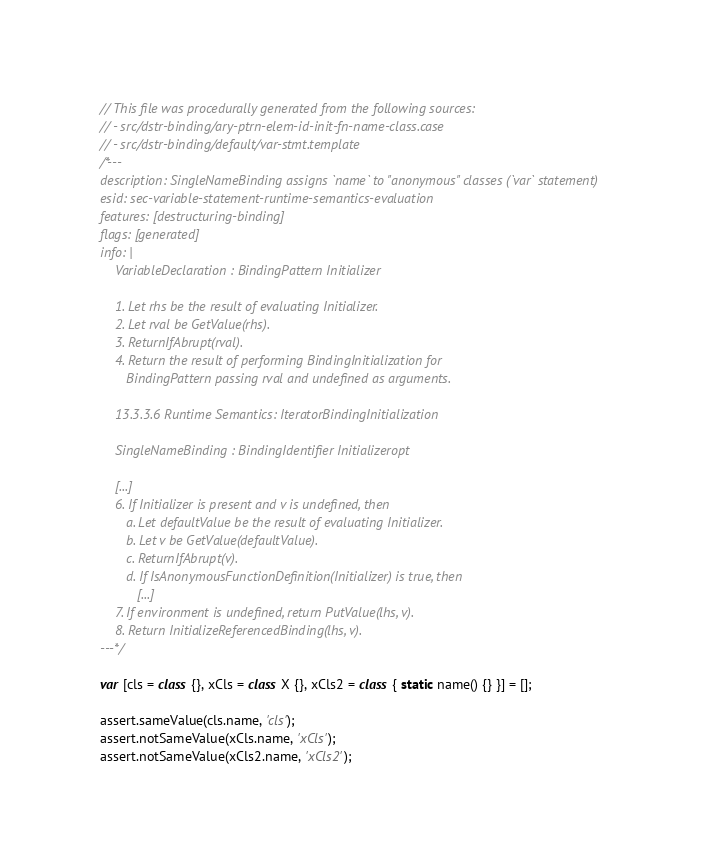Convert code to text. <code><loc_0><loc_0><loc_500><loc_500><_JavaScript_>// This file was procedurally generated from the following sources:
// - src/dstr-binding/ary-ptrn-elem-id-init-fn-name-class.case
// - src/dstr-binding/default/var-stmt.template
/*---
description: SingleNameBinding assigns `name` to "anonymous" classes (`var` statement)
esid: sec-variable-statement-runtime-semantics-evaluation
features: [destructuring-binding]
flags: [generated]
info: |
    VariableDeclaration : BindingPattern Initializer

    1. Let rhs be the result of evaluating Initializer.
    2. Let rval be GetValue(rhs).
    3. ReturnIfAbrupt(rval).
    4. Return the result of performing BindingInitialization for
       BindingPattern passing rval and undefined as arguments.

    13.3.3.6 Runtime Semantics: IteratorBindingInitialization

    SingleNameBinding : BindingIdentifier Initializeropt

    [...]
    6. If Initializer is present and v is undefined, then
       a. Let defaultValue be the result of evaluating Initializer.
       b. Let v be GetValue(defaultValue).
       c. ReturnIfAbrupt(v).
       d. If IsAnonymousFunctionDefinition(Initializer) is true, then
          [...]
    7. If environment is undefined, return PutValue(lhs, v).
    8. Return InitializeReferencedBinding(lhs, v).
---*/

var [cls = class {}, xCls = class X {}, xCls2 = class { static name() {} }] = [];

assert.sameValue(cls.name, 'cls');
assert.notSameValue(xCls.name, 'xCls');
assert.notSameValue(xCls2.name, 'xCls2');
</code> 